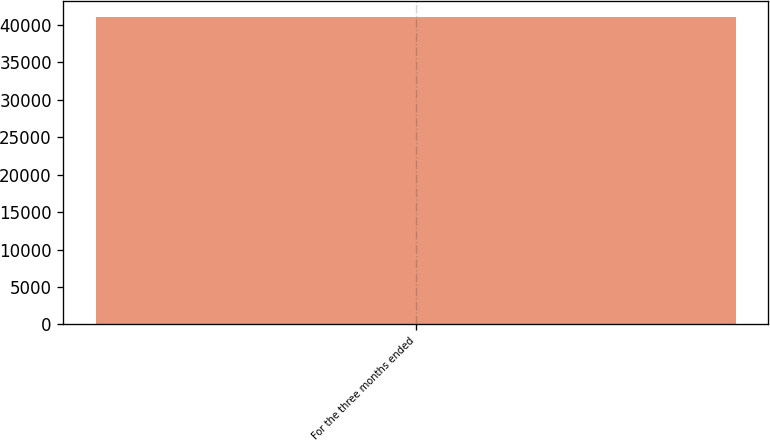Convert chart to OTSL. <chart><loc_0><loc_0><loc_500><loc_500><bar_chart><fcel>For the three months ended<nl><fcel>41090<nl></chart> 